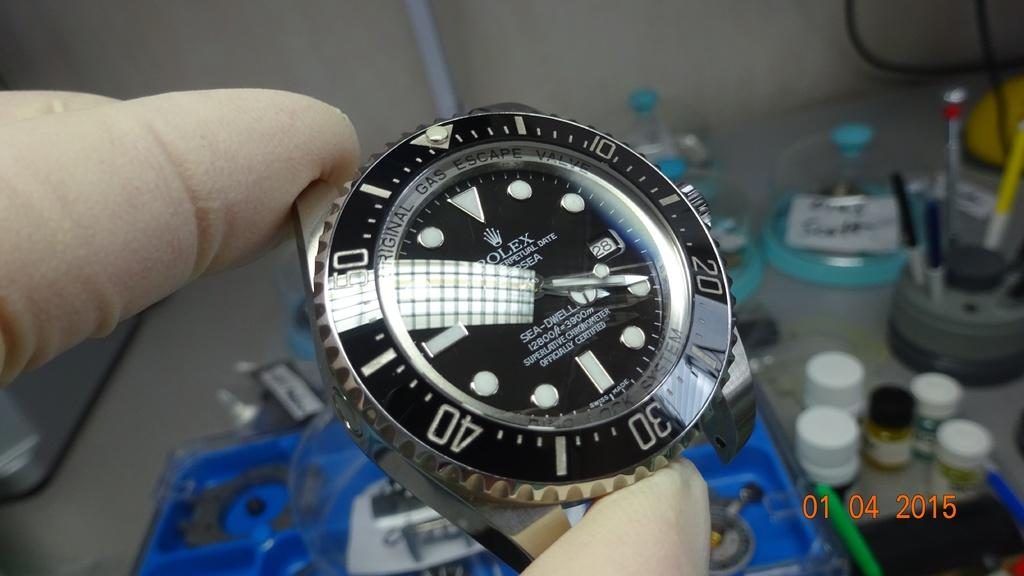<image>
Create a compact narrative representing the image presented. A photo of a bandless watch that was taken in January of 2015. 